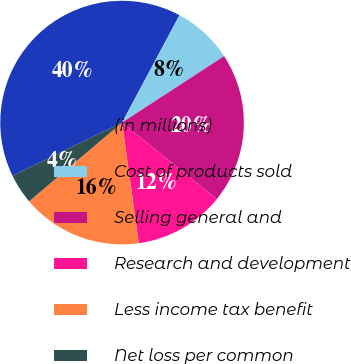<chart> <loc_0><loc_0><loc_500><loc_500><pie_chart><fcel>(in millions)<fcel>Cost of products sold<fcel>Selling general and<fcel>Research and development<fcel>Less income tax benefit<fcel>Net loss per common<nl><fcel>40.0%<fcel>8.0%<fcel>20.0%<fcel>12.0%<fcel>16.0%<fcel>4.0%<nl></chart> 